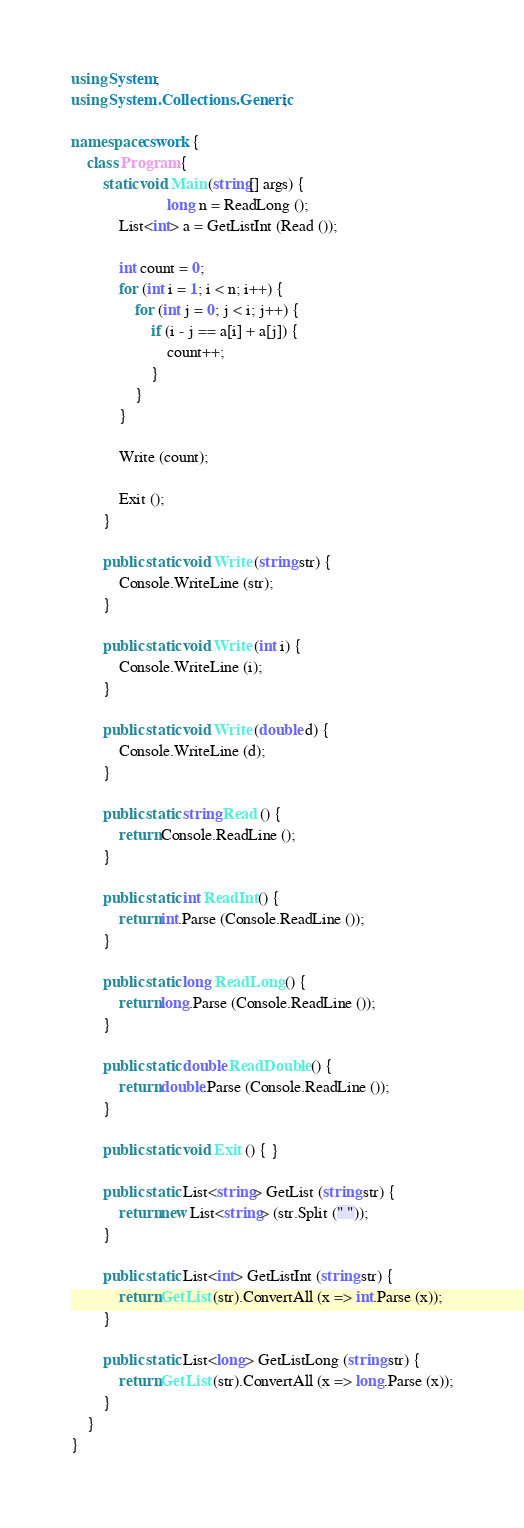<code> <loc_0><loc_0><loc_500><loc_500><_C#_>using System;
using System.Collections.Generic;

namespace cswork {
    class Program {
        static void Main (string[] args) {
                        long n = ReadLong ();
            List<int> a = GetListInt (Read ());

            int count = 0;
            for (int i = 1; i < n; i++) {
                for (int j = 0; j < i; j++) {
                    if (i - j == a[i] + a[j]) {
                        count++;
                    }
                }
            }

            Write (count);

            Exit ();
        }

        public static void Write (string str) {
            Console.WriteLine (str);
        }

        public static void Write (int i) {
            Console.WriteLine (i);
        }

        public static void Write (double d) {
            Console.WriteLine (d);
        }

        public static string Read () {
            return Console.ReadLine ();
        }

        public static int ReadInt () {
            return int.Parse (Console.ReadLine ());
        }

        public static long ReadLong () {
            return long.Parse (Console.ReadLine ());
        }

        public static double ReadDouble () {
            return double.Parse (Console.ReadLine ());
        }

        public static void Exit () { }

        public static List<string> GetList (string str) {
            return new List<string> (str.Split (" "));
        }

        public static List<int> GetListInt (string str) {
            return GetList (str).ConvertAll (x => int.Parse (x));
        }

        public static List<long> GetListLong (string str) {
            return GetList (str).ConvertAll (x => long.Parse (x));
        }
    }
}</code> 